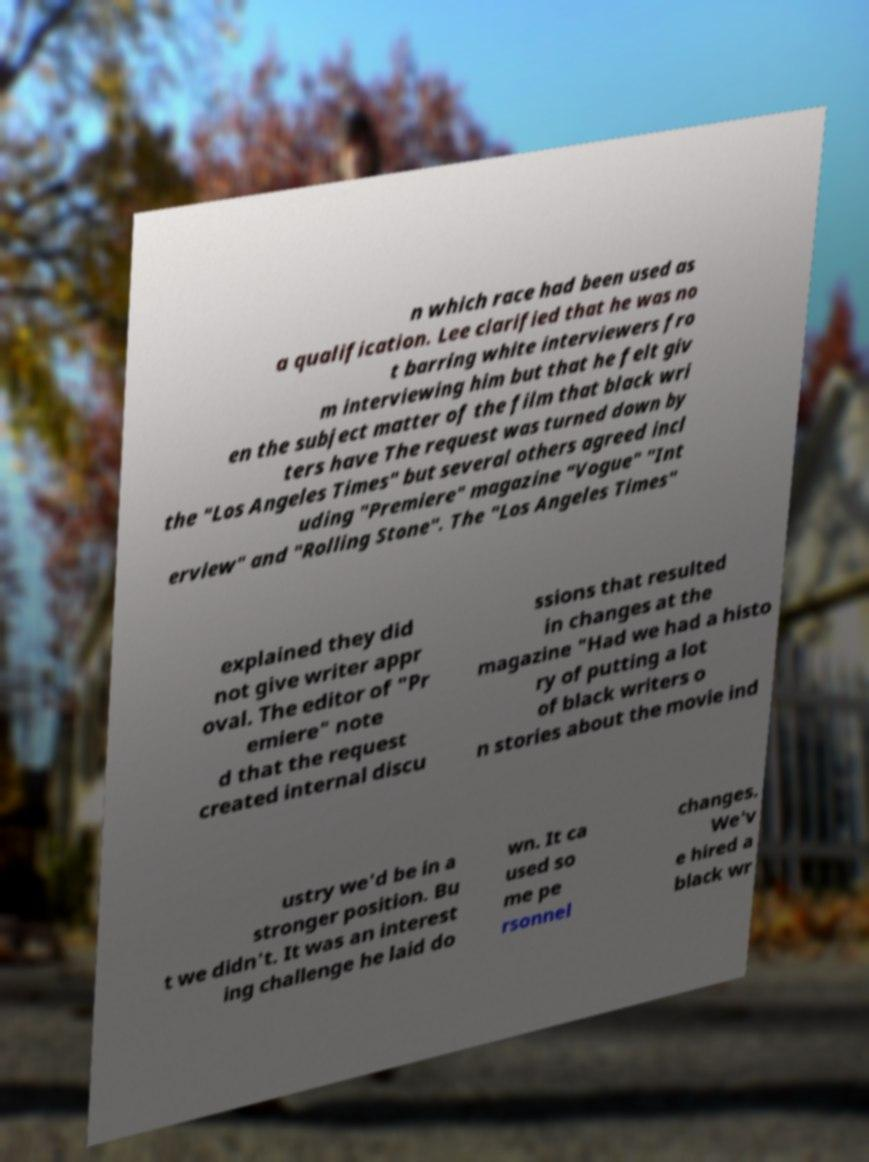Can you read and provide the text displayed in the image?This photo seems to have some interesting text. Can you extract and type it out for me? n which race had been used as a qualification. Lee clarified that he was no t barring white interviewers fro m interviewing him but that he felt giv en the subject matter of the film that black wri ters have The request was turned down by the "Los Angeles Times" but several others agreed incl uding "Premiere" magazine "Vogue" "Int erview" and "Rolling Stone". The "Los Angeles Times" explained they did not give writer appr oval. The editor of "Pr emiere" note d that the request created internal discu ssions that resulted in changes at the magazine "Had we had a histo ry of putting a lot of black writers o n stories about the movie ind ustry we'd be in a stronger position. Bu t we didn't. It was an interest ing challenge he laid do wn. It ca used so me pe rsonnel changes. We'v e hired a black wr 